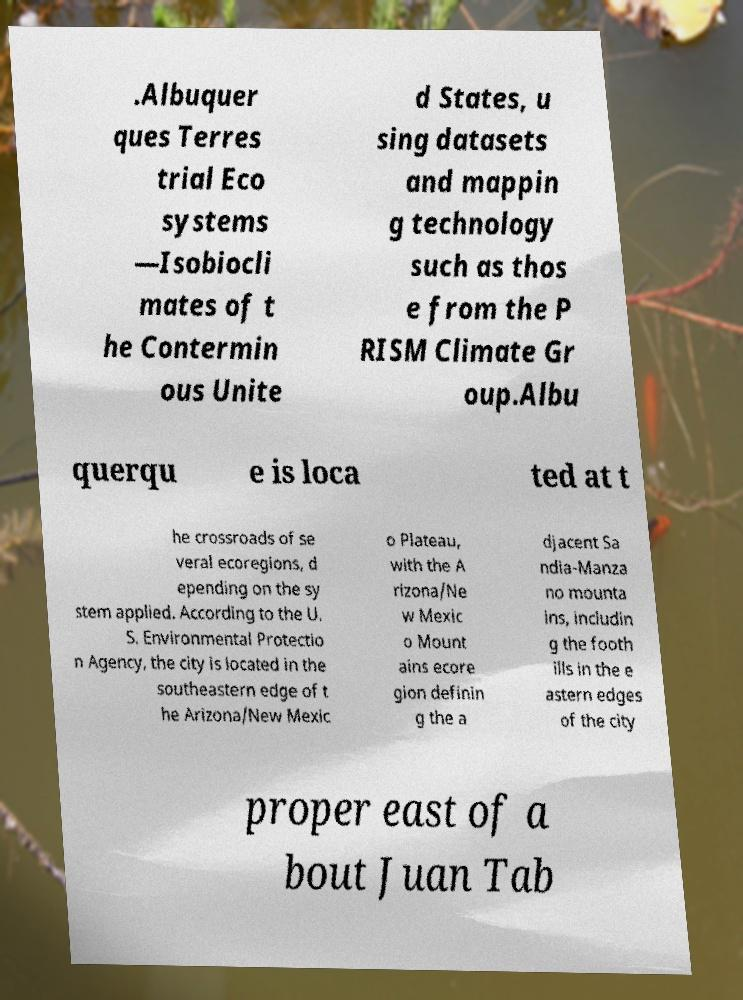Could you extract and type out the text from this image? .Albuquer ques Terres trial Eco systems —Isobiocli mates of t he Contermin ous Unite d States, u sing datasets and mappin g technology such as thos e from the P RISM Climate Gr oup.Albu querqu e is loca ted at t he crossroads of se veral ecoregions, d epending on the sy stem applied. According to the U. S. Environmental Protectio n Agency, the city is located in the southeastern edge of t he Arizona/New Mexic o Plateau, with the A rizona/Ne w Mexic o Mount ains ecore gion definin g the a djacent Sa ndia-Manza no mounta ins, includin g the footh ills in the e astern edges of the city proper east of a bout Juan Tab 